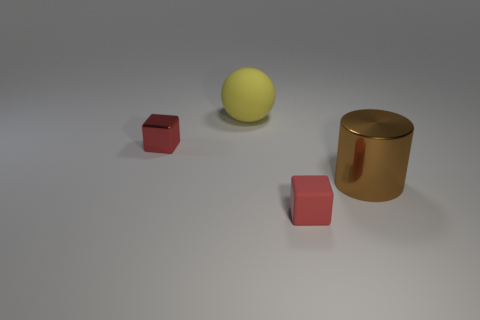Add 3 big brown things. How many objects exist? 7 Subtract all balls. How many objects are left? 3 Add 3 yellow matte balls. How many yellow matte balls are left? 4 Add 3 large brown cylinders. How many large brown cylinders exist? 4 Subtract 0 blue spheres. How many objects are left? 4 Subtract all tiny red metallic objects. Subtract all yellow things. How many objects are left? 2 